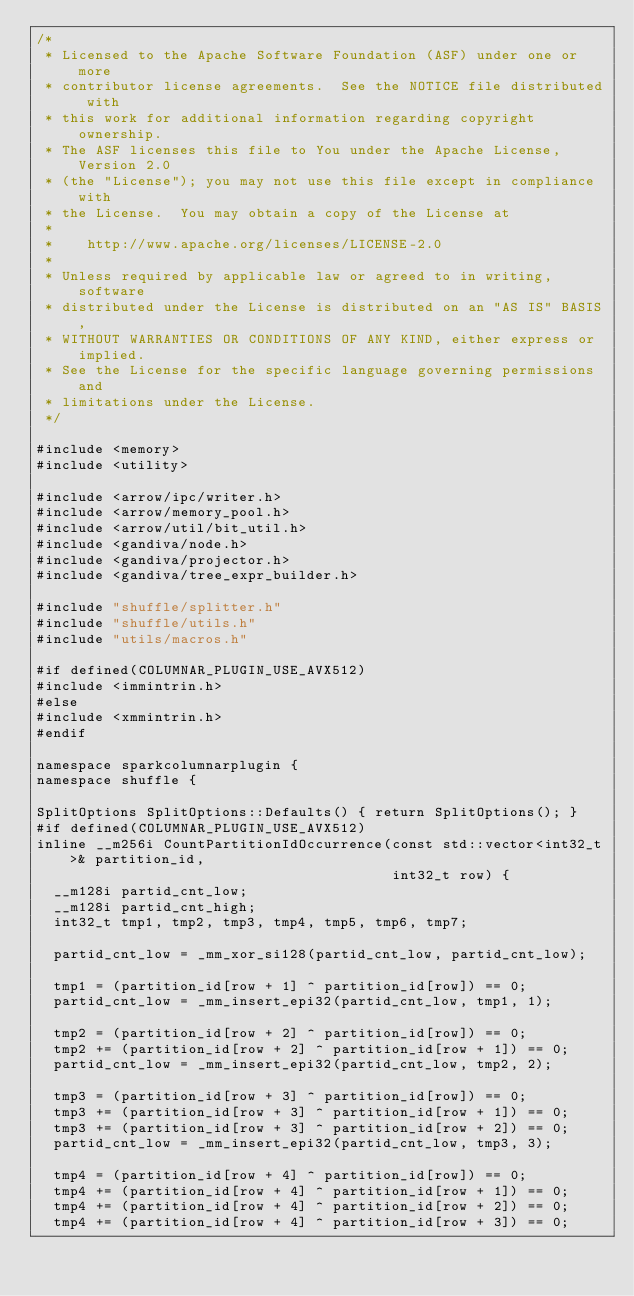Convert code to text. <code><loc_0><loc_0><loc_500><loc_500><_C++_>/*
 * Licensed to the Apache Software Foundation (ASF) under one or more
 * contributor license agreements.  See the NOTICE file distributed with
 * this work for additional information regarding copyright ownership.
 * The ASF licenses this file to You under the Apache License, Version 2.0
 * (the "License"); you may not use this file except in compliance with
 * the License.  You may obtain a copy of the License at
 *
 *    http://www.apache.org/licenses/LICENSE-2.0
 *
 * Unless required by applicable law or agreed to in writing, software
 * distributed under the License is distributed on an "AS IS" BASIS,
 * WITHOUT WARRANTIES OR CONDITIONS OF ANY KIND, either express or implied.
 * See the License for the specific language governing permissions and
 * limitations under the License.
 */

#include <memory>
#include <utility>

#include <arrow/ipc/writer.h>
#include <arrow/memory_pool.h>
#include <arrow/util/bit_util.h>
#include <gandiva/node.h>
#include <gandiva/projector.h>
#include <gandiva/tree_expr_builder.h>

#include "shuffle/splitter.h"
#include "shuffle/utils.h"
#include "utils/macros.h"

#if defined(COLUMNAR_PLUGIN_USE_AVX512)
#include <immintrin.h>
#else
#include <xmmintrin.h>
#endif

namespace sparkcolumnarplugin {
namespace shuffle {

SplitOptions SplitOptions::Defaults() { return SplitOptions(); }
#if defined(COLUMNAR_PLUGIN_USE_AVX512)
inline __m256i CountPartitionIdOccurrence(const std::vector<int32_t>& partition_id,
                                          int32_t row) {
  __m128i partid_cnt_low;
  __m128i partid_cnt_high;
  int32_t tmp1, tmp2, tmp3, tmp4, tmp5, tmp6, tmp7;

  partid_cnt_low = _mm_xor_si128(partid_cnt_low, partid_cnt_low);

  tmp1 = (partition_id[row + 1] ^ partition_id[row]) == 0;
  partid_cnt_low = _mm_insert_epi32(partid_cnt_low, tmp1, 1);

  tmp2 = (partition_id[row + 2] ^ partition_id[row]) == 0;
  tmp2 += (partition_id[row + 2] ^ partition_id[row + 1]) == 0;
  partid_cnt_low = _mm_insert_epi32(partid_cnt_low, tmp2, 2);

  tmp3 = (partition_id[row + 3] ^ partition_id[row]) == 0;
  tmp3 += (partition_id[row + 3] ^ partition_id[row + 1]) == 0;
  tmp3 += (partition_id[row + 3] ^ partition_id[row + 2]) == 0;
  partid_cnt_low = _mm_insert_epi32(partid_cnt_low, tmp3, 3);

  tmp4 = (partition_id[row + 4] ^ partition_id[row]) == 0;
  tmp4 += (partition_id[row + 4] ^ partition_id[row + 1]) == 0;
  tmp4 += (partition_id[row + 4] ^ partition_id[row + 2]) == 0;
  tmp4 += (partition_id[row + 4] ^ partition_id[row + 3]) == 0;</code> 